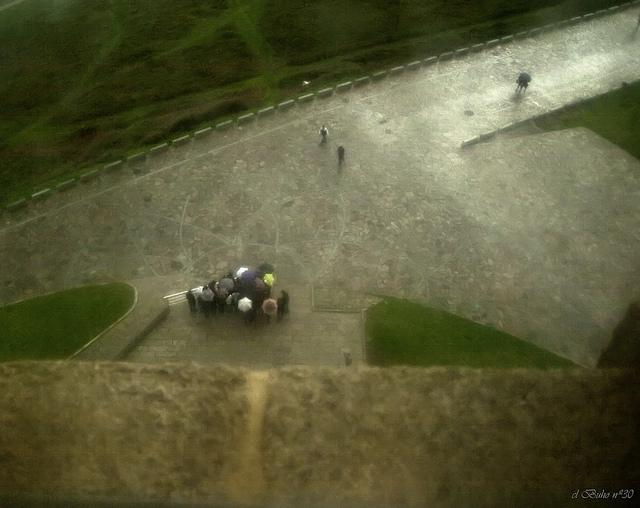What are the objects held in the small group of people at the mouth of this road?

Choices:
A) rainjackets
B) pianos
C) windex
D) umbrellas umbrellas 